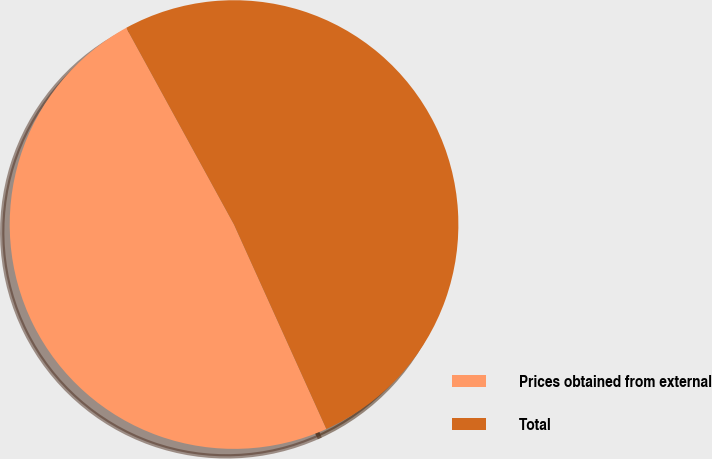Convert chart. <chart><loc_0><loc_0><loc_500><loc_500><pie_chart><fcel>Prices obtained from external<fcel>Total<nl><fcel>48.78%<fcel>51.22%<nl></chart> 